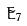<formula> <loc_0><loc_0><loc_500><loc_500>\tilde { E } _ { 7 }</formula> 